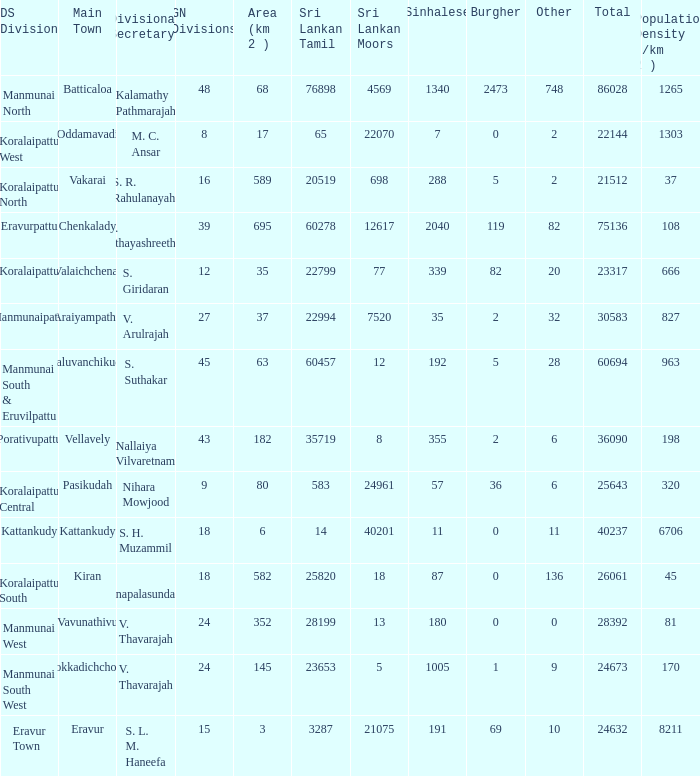What is the name of the DS division where the divisional secretary is S. H. Muzammil? Kattankudy. 